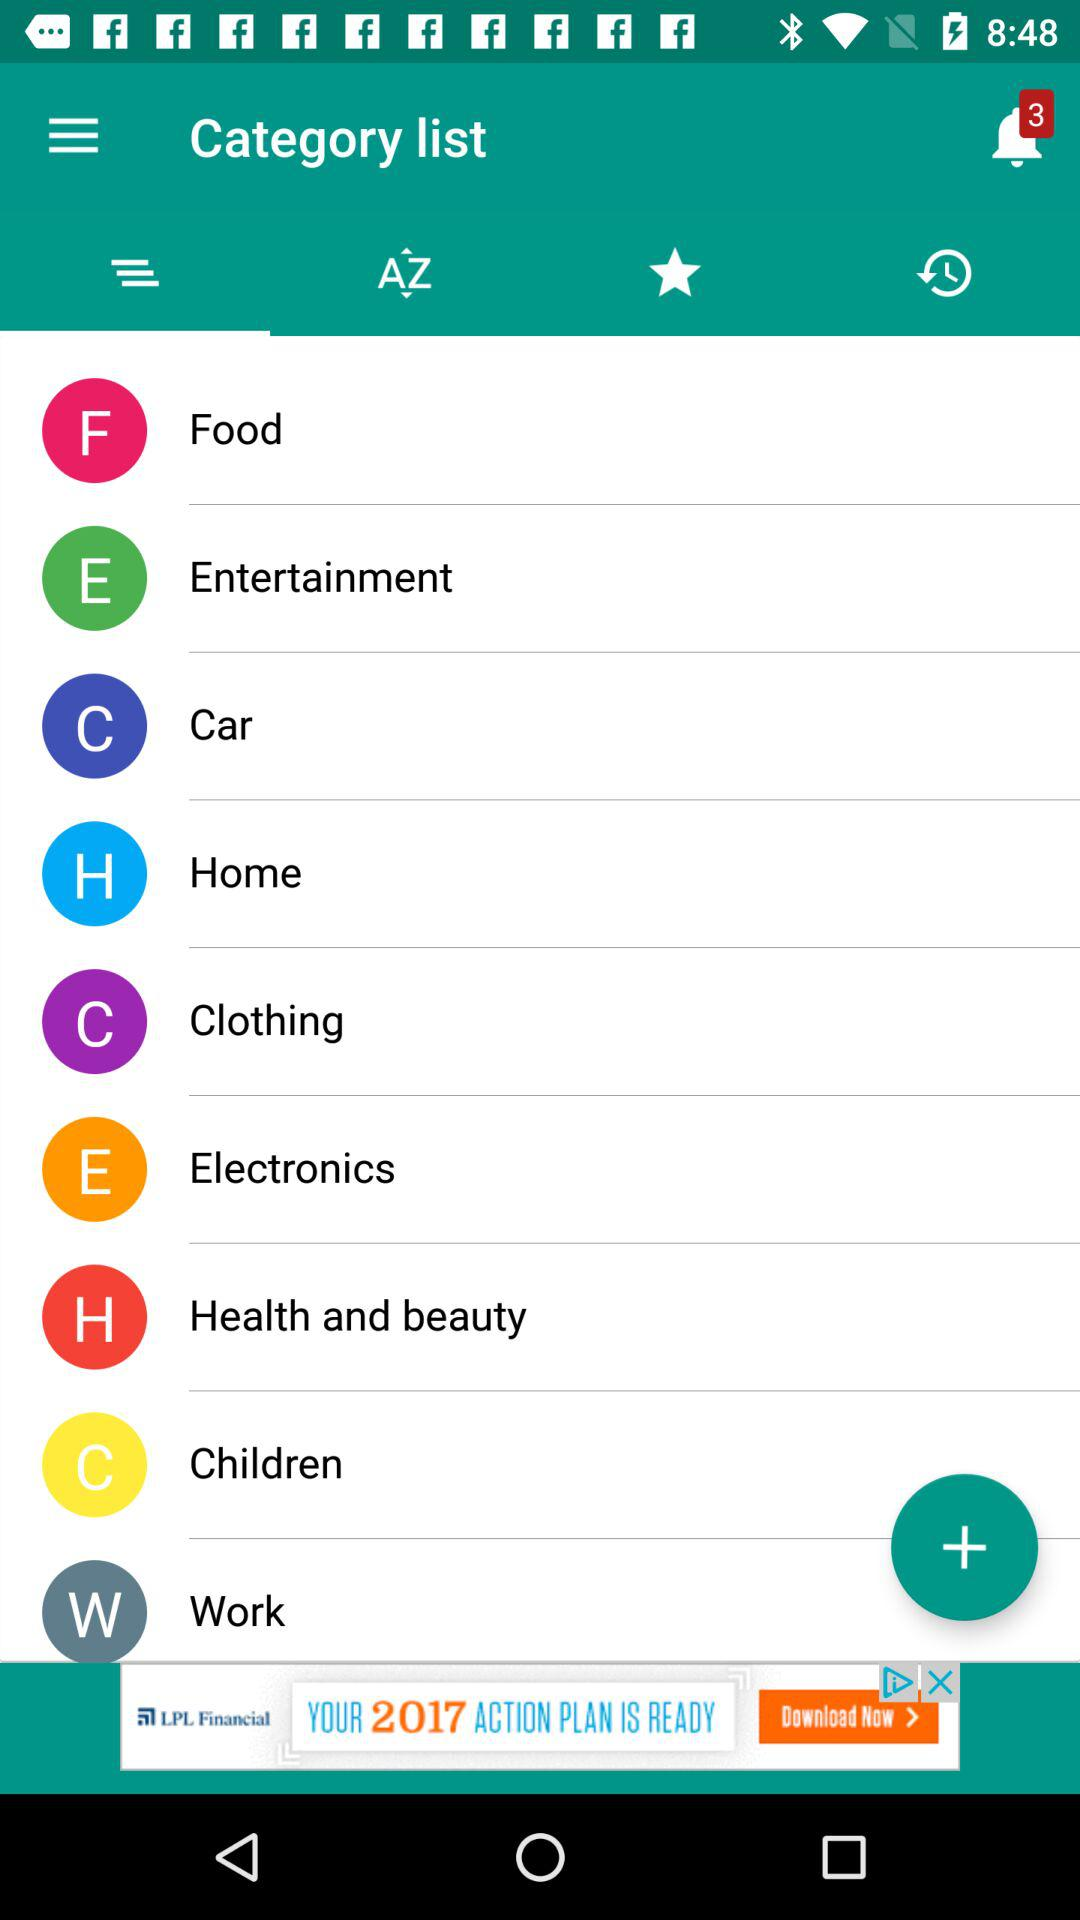What is the count of notifications? The count of notifications is 3. 